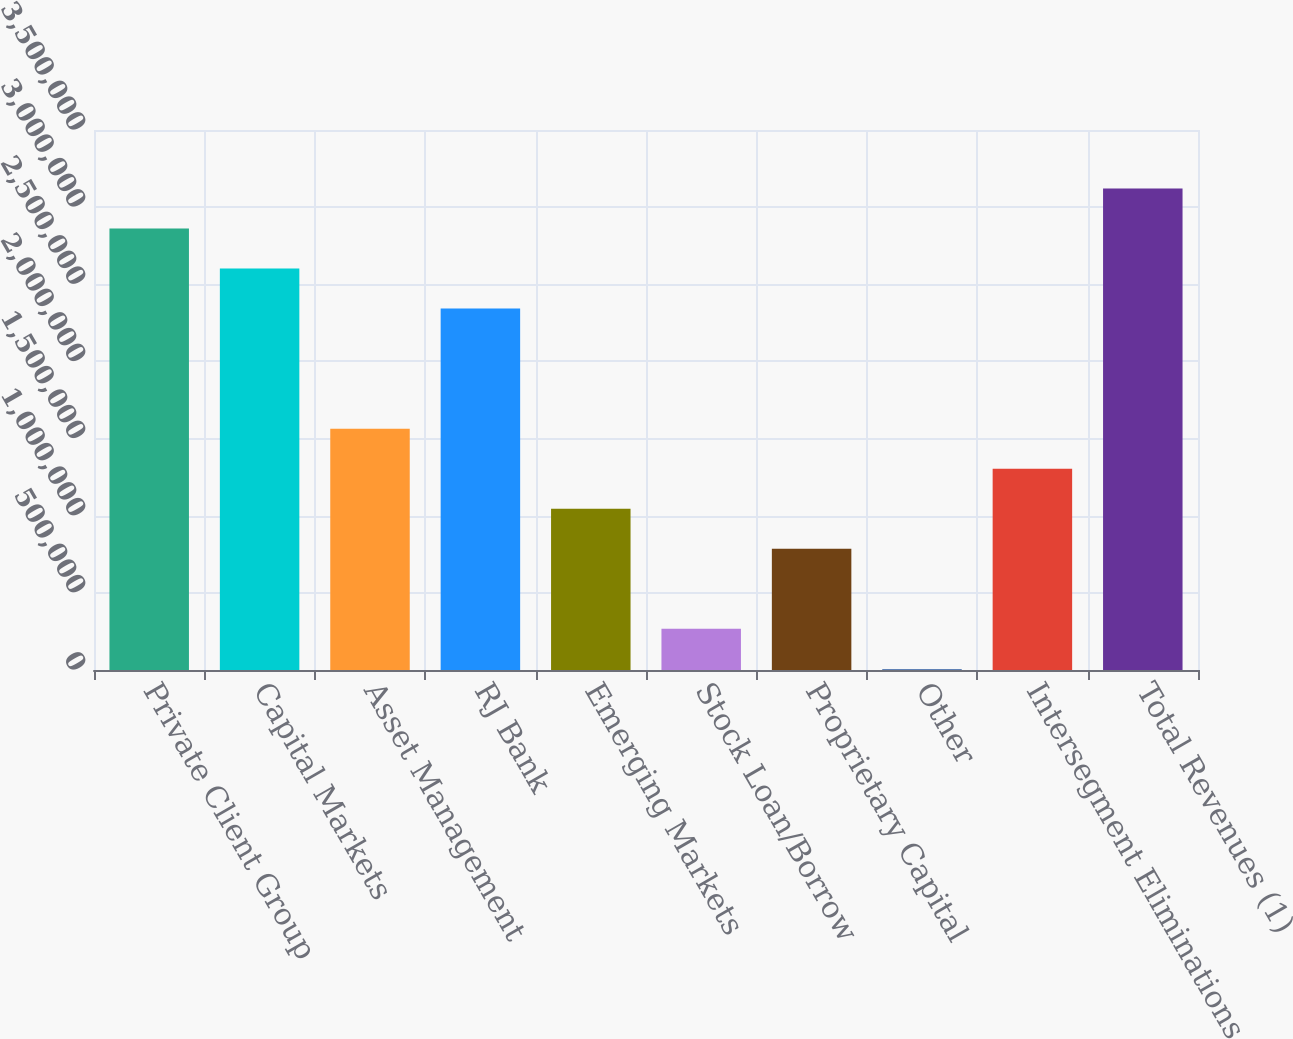<chart> <loc_0><loc_0><loc_500><loc_500><bar_chart><fcel>Private Client Group<fcel>Capital Markets<fcel>Asset Management<fcel>RJ Bank<fcel>Emerging Markets<fcel>Stock Loan/Borrow<fcel>Proprietary Capital<fcel>Other<fcel>Intersegment Eliminations<fcel>Total Revenues (1)<nl><fcel>2.86206e+06<fcel>2.60252e+06<fcel>1.56437e+06<fcel>2.34298e+06<fcel>1.0453e+06<fcel>266690<fcel>785763<fcel>7153<fcel>1.30484e+06<fcel>3.12159e+06<nl></chart> 